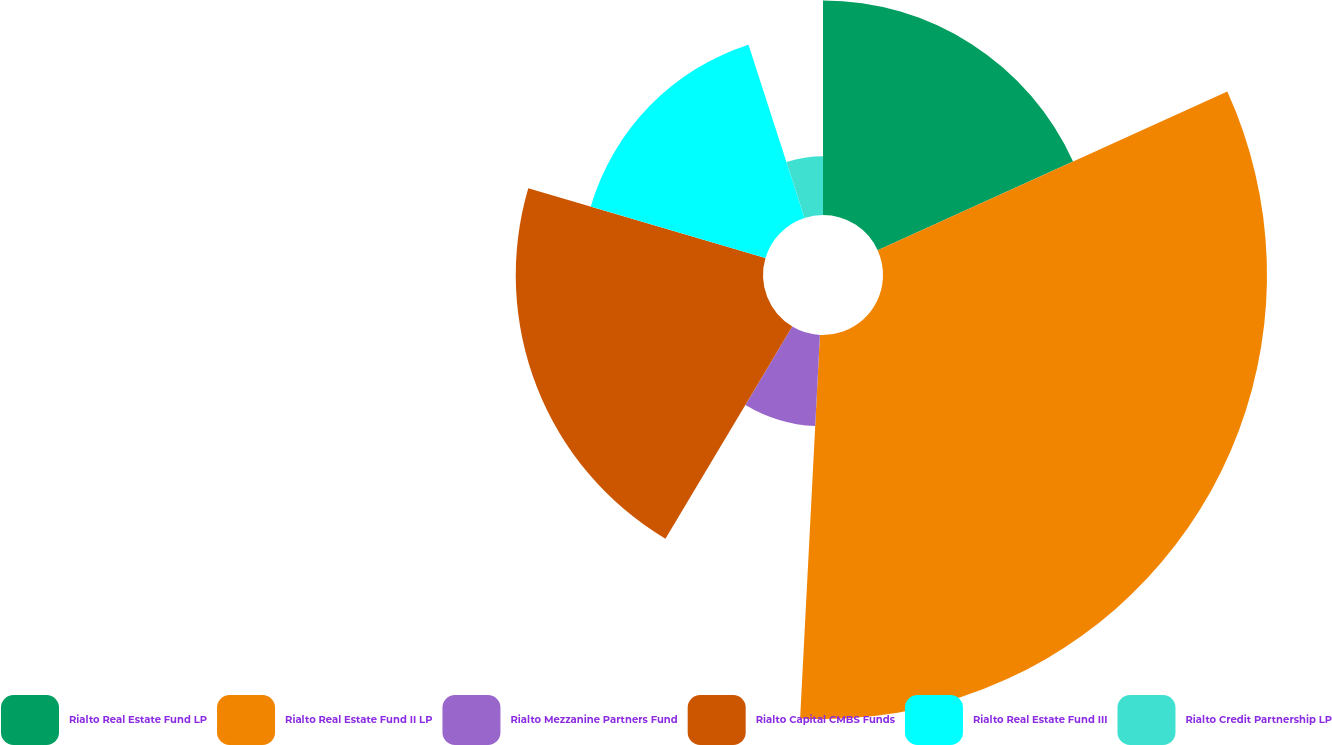<chart> <loc_0><loc_0><loc_500><loc_500><pie_chart><fcel>Rialto Real Estate Fund LP<fcel>Rialto Real Estate Fund II LP<fcel>Rialto Mezzanine Partners Fund<fcel>Rialto Capital CMBS Funds<fcel>Rialto Real Estate Fund III<fcel>Rialto Credit Partnership LP<nl><fcel>18.22%<fcel>32.6%<fcel>7.75%<fcel>20.99%<fcel>15.46%<fcel>4.98%<nl></chart> 